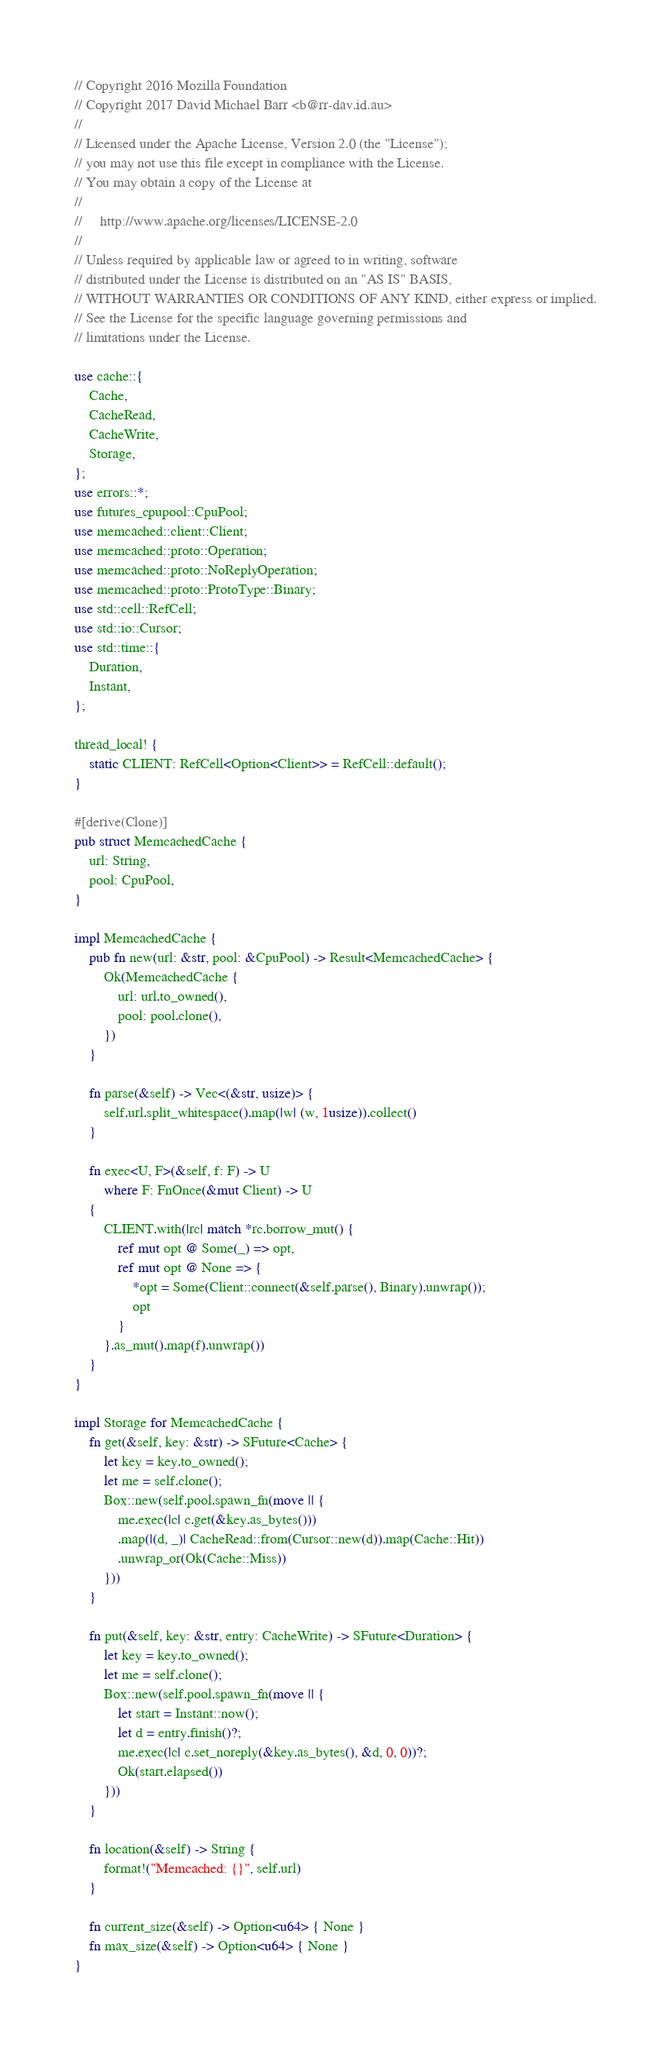Convert code to text. <code><loc_0><loc_0><loc_500><loc_500><_Rust_>// Copyright 2016 Mozilla Foundation
// Copyright 2017 David Michael Barr <b@rr-dav.id.au>
//
// Licensed under the Apache License, Version 2.0 (the "License");
// you may not use this file except in compliance with the License.
// You may obtain a copy of the License at
//
//     http://www.apache.org/licenses/LICENSE-2.0
//
// Unless required by applicable law or agreed to in writing, software
// distributed under the License is distributed on an "AS IS" BASIS,
// WITHOUT WARRANTIES OR CONDITIONS OF ANY KIND, either express or implied.
// See the License for the specific language governing permissions and
// limitations under the License.

use cache::{
    Cache,
    CacheRead,
    CacheWrite,
    Storage,
};
use errors::*;
use futures_cpupool::CpuPool;
use memcached::client::Client;
use memcached::proto::Operation;
use memcached::proto::NoReplyOperation;
use memcached::proto::ProtoType::Binary;
use std::cell::RefCell;
use std::io::Cursor;
use std::time::{
    Duration,
    Instant,
};

thread_local! {
    static CLIENT: RefCell<Option<Client>> = RefCell::default();
}

#[derive(Clone)]
pub struct MemcachedCache {
    url: String,
    pool: CpuPool,
}

impl MemcachedCache {
    pub fn new(url: &str, pool: &CpuPool) -> Result<MemcachedCache> {
        Ok(MemcachedCache {
            url: url.to_owned(),
            pool: pool.clone(),
        })
    }

    fn parse(&self) -> Vec<(&str, usize)> {
        self.url.split_whitespace().map(|w| (w, 1usize)).collect()
    }

    fn exec<U, F>(&self, f: F) -> U
        where F: FnOnce(&mut Client) -> U
    {
        CLIENT.with(|rc| match *rc.borrow_mut() {
            ref mut opt @ Some(_) => opt,
            ref mut opt @ None => {
                *opt = Some(Client::connect(&self.parse(), Binary).unwrap());
                opt
            }
        }.as_mut().map(f).unwrap())
    }
}

impl Storage for MemcachedCache {
    fn get(&self, key: &str) -> SFuture<Cache> {
        let key = key.to_owned();
        let me = self.clone();
        Box::new(self.pool.spawn_fn(move || {
            me.exec(|c| c.get(&key.as_bytes()))
            .map(|(d, _)| CacheRead::from(Cursor::new(d)).map(Cache::Hit))
            .unwrap_or(Ok(Cache::Miss))
        }))
    }

    fn put(&self, key: &str, entry: CacheWrite) -> SFuture<Duration> {
        let key = key.to_owned();
        let me = self.clone();
        Box::new(self.pool.spawn_fn(move || {
            let start = Instant::now();
            let d = entry.finish()?;
            me.exec(|c| c.set_noreply(&key.as_bytes(), &d, 0, 0))?;
            Ok(start.elapsed())
        }))
    }

    fn location(&self) -> String {
        format!("Memcached: {}", self.url)
    }

    fn current_size(&self) -> Option<u64> { None }
    fn max_size(&self) -> Option<u64> { None }
}
</code> 